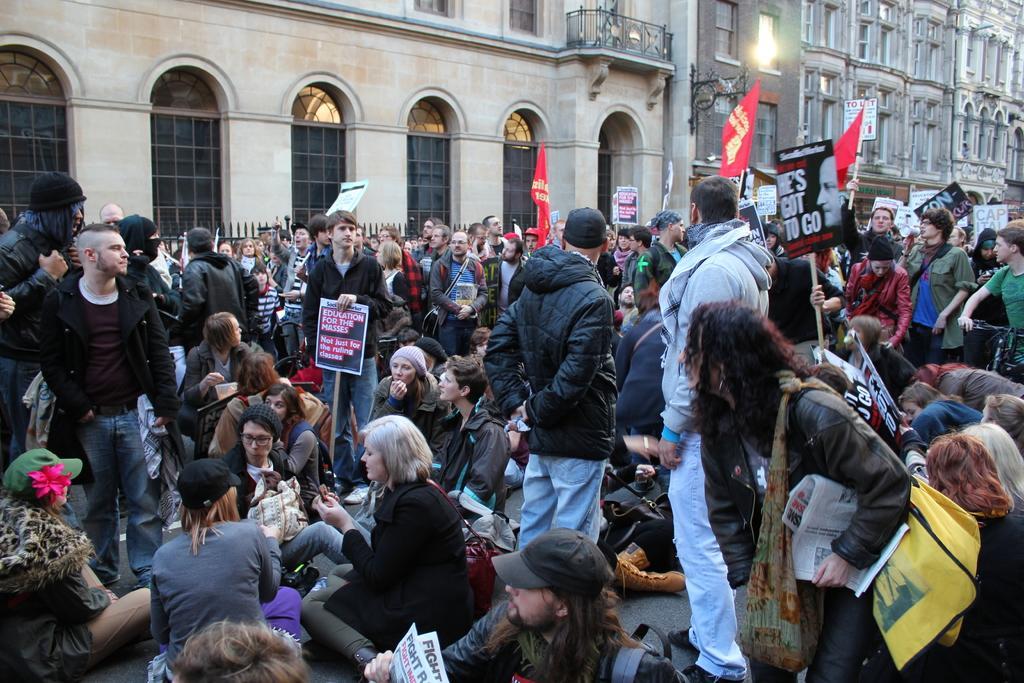How would you summarize this image in a sentence or two? In this picture there are group of people sitting and there are group of people standing and few people are holding the placards and flags and there is text on the placards and flags. At the back there are buildings and there is a railing and there is a board and light on the wall. At the bottom there is a road. 